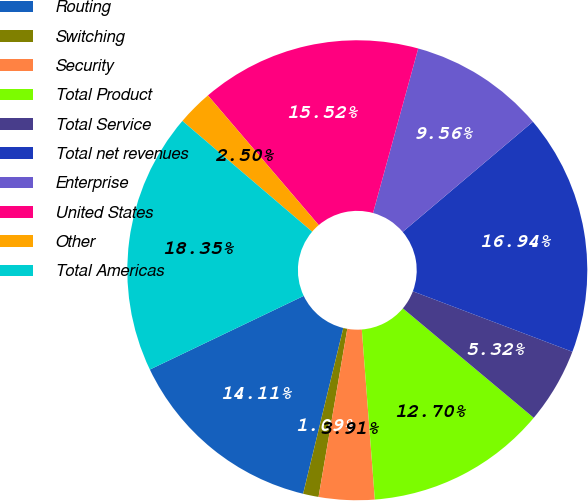Convert chart to OTSL. <chart><loc_0><loc_0><loc_500><loc_500><pie_chart><fcel>Routing<fcel>Switching<fcel>Security<fcel>Total Product<fcel>Total Service<fcel>Total net revenues<fcel>Enterprise<fcel>United States<fcel>Other<fcel>Total Americas<nl><fcel>14.11%<fcel>1.09%<fcel>3.91%<fcel>12.7%<fcel>5.32%<fcel>16.94%<fcel>9.56%<fcel>15.52%<fcel>2.5%<fcel>18.35%<nl></chart> 